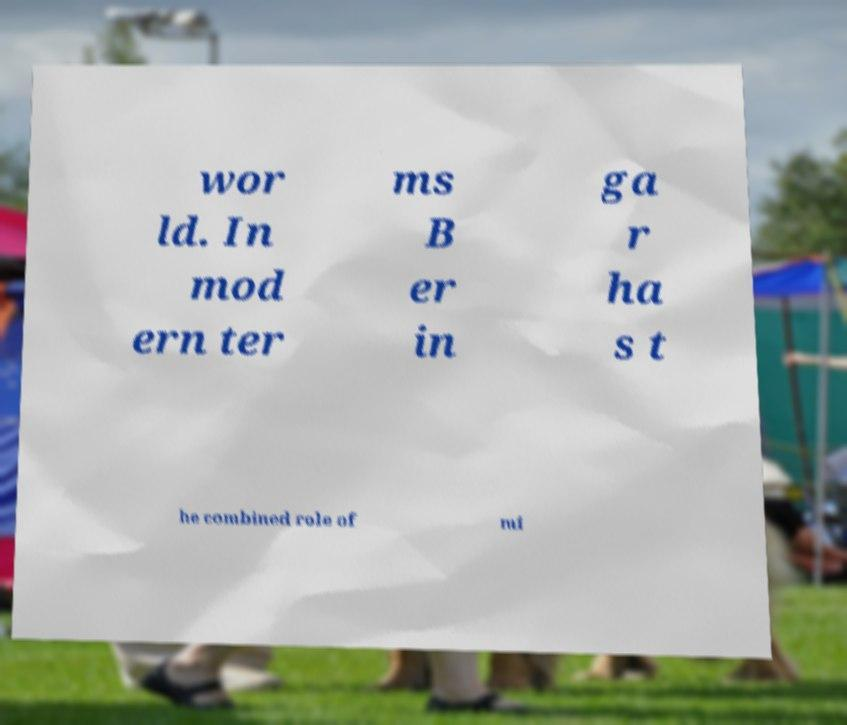There's text embedded in this image that I need extracted. Can you transcribe it verbatim? wor ld. In mod ern ter ms B er in ga r ha s t he combined role of mi 